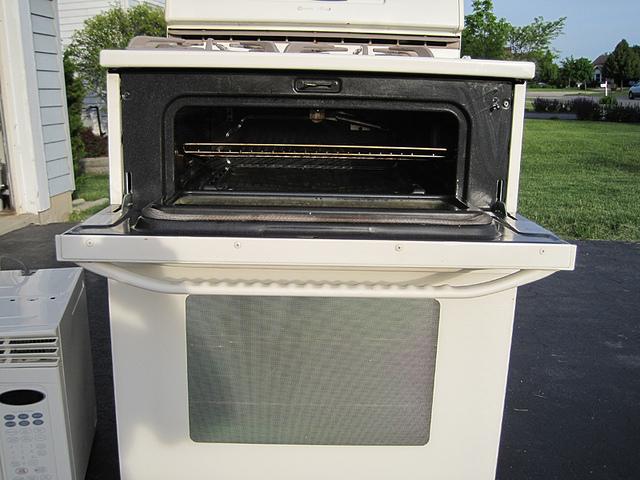What kind of siding is on this house?
Answer briefly. Vinyl. What kind of food can you cook in that toaster oven?
Give a very brief answer. Toast. What item is to the left of the toaster oven?
Answer briefly. Microwave. 